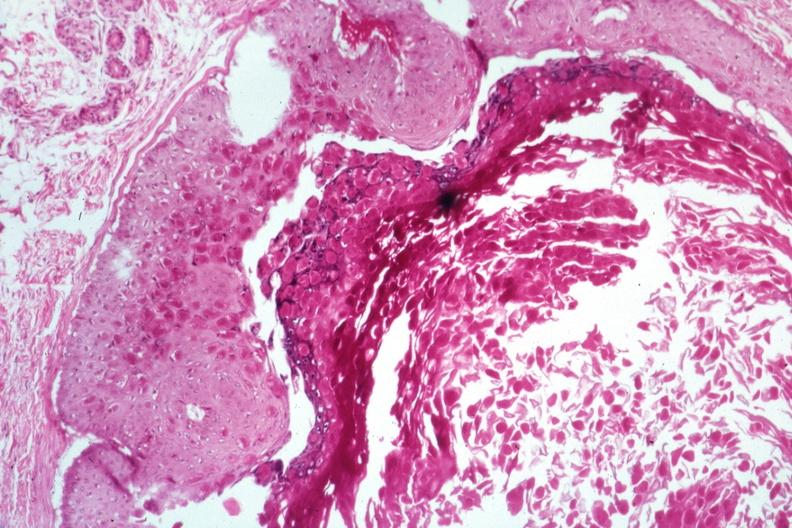s molluscum contagiosum present?
Answer the question using a single word or phrase. Yes 